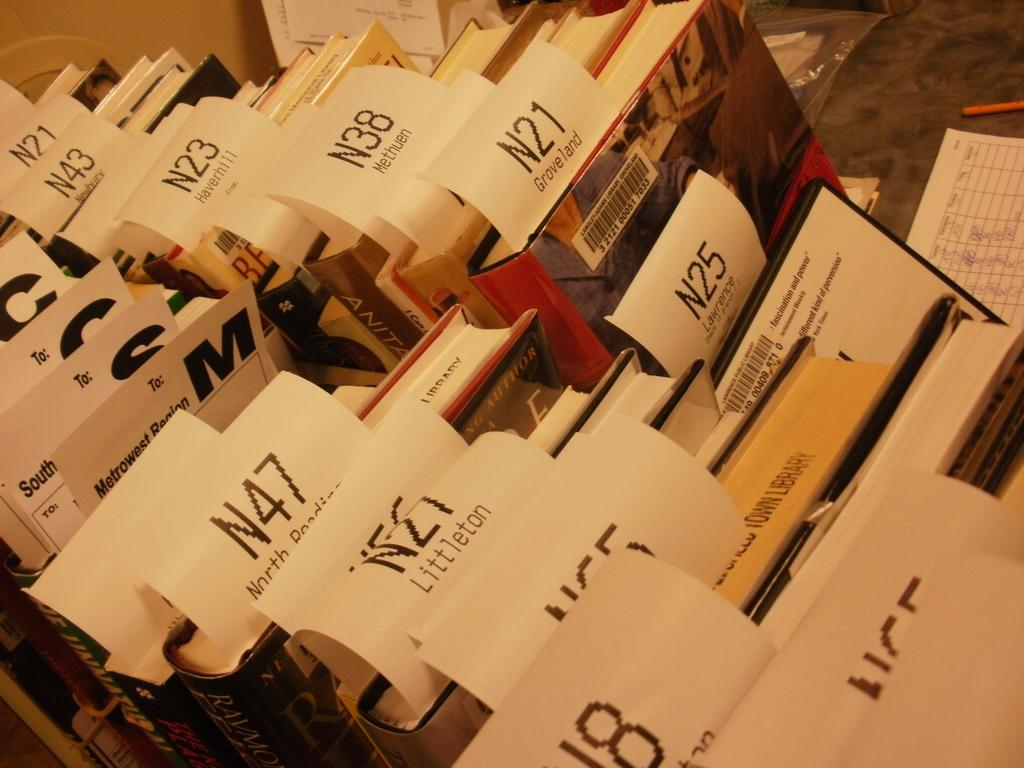<image>
Offer a succinct explanation of the picture presented. Books that are all Numbered with the letter N and a different number on each book. 